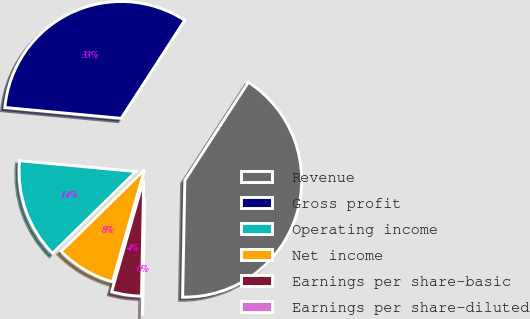Convert chart to OTSL. <chart><loc_0><loc_0><loc_500><loc_500><pie_chart><fcel>Revenue<fcel>Gross profit<fcel>Operating income<fcel>Net income<fcel>Earnings per share-basic<fcel>Earnings per share-diluted<nl><fcel>41.15%<fcel>32.67%<fcel>13.83%<fcel>8.23%<fcel>4.12%<fcel>0.0%<nl></chart> 